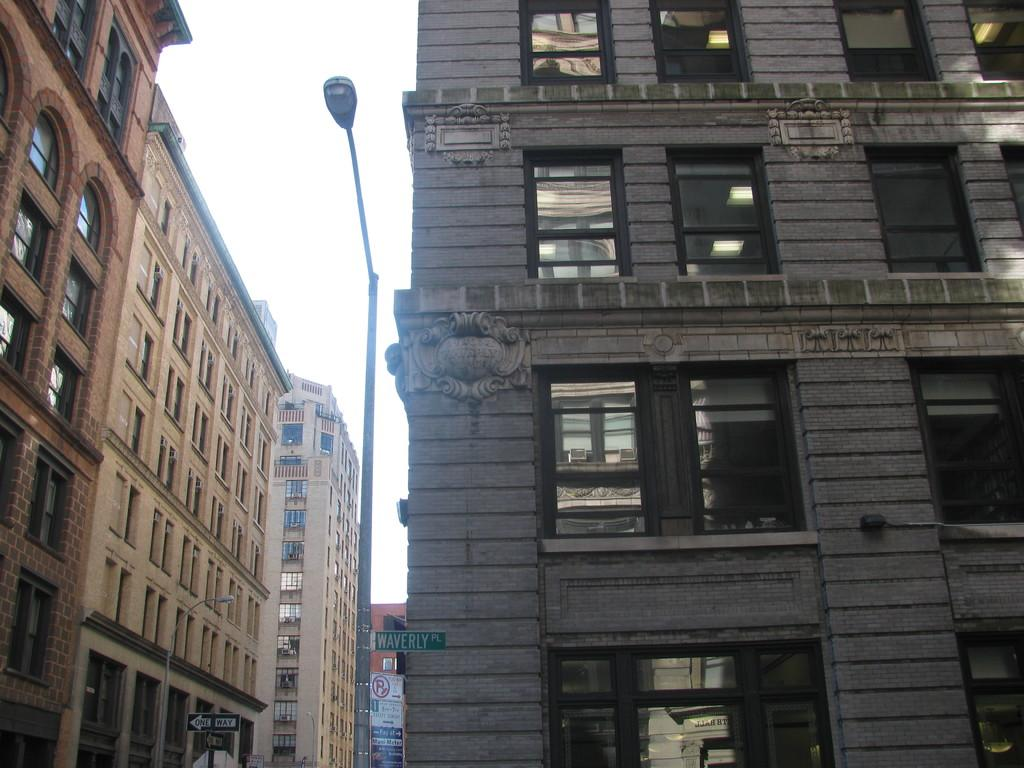What type of building can be seen in the image? There is a building with glass windows in the image. What other object is present in the image? There is a street pole in the image. How many brown-colored buildings with many windows are visible in the image? There are two brown-colored buildings with many windows in the image. What type of clam is being served in the soup during the afternoon in the image? There is no soup or clam present in the image; it features a building with glass windows, a street pole, and two brown-colored buildings with many windows. 